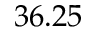Convert formula to latex. <formula><loc_0><loc_0><loc_500><loc_500>3 6 . 2 5</formula> 